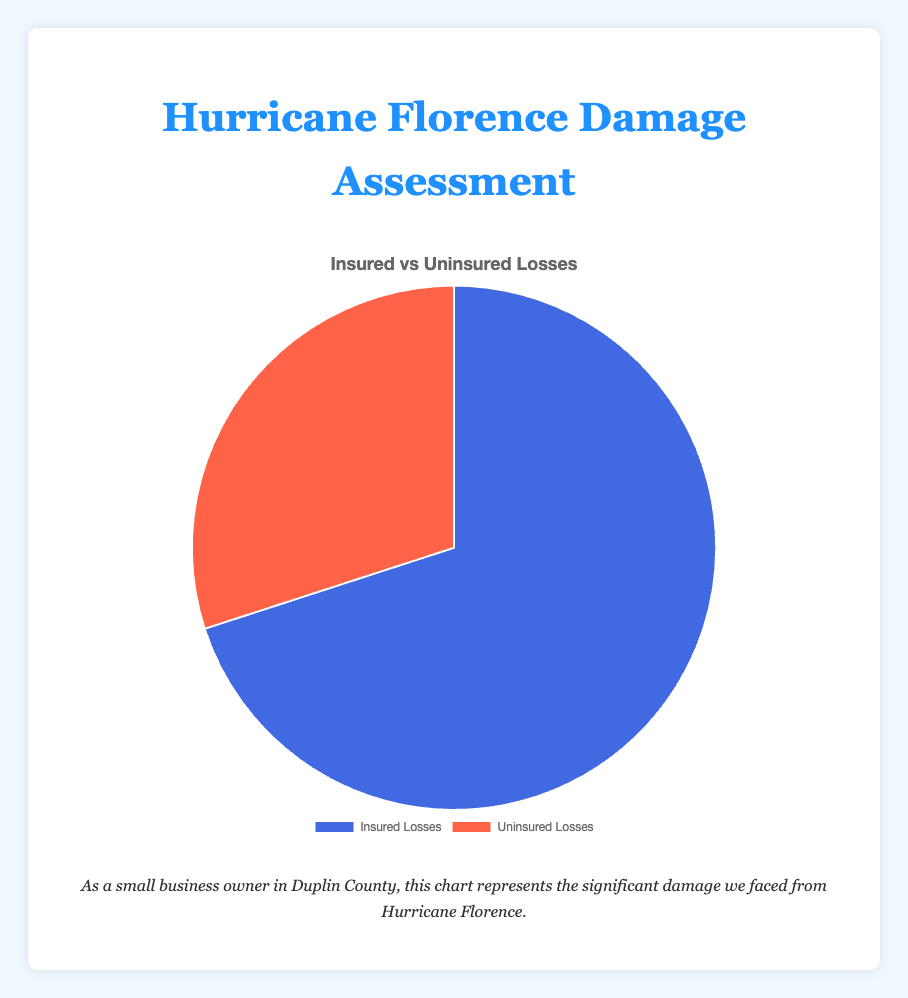What's the total value of uninsured losses? The figure shows that the pie chart represents uninsured losses as one segment, and its value is displayed as $1,500,000.
Answer: $1,500,000 What proportion of the total losses do insured losses represent? Insured losses are $3,500,000 out of a total loss of $5,000,000. To find the proportion, divide $3,500,000 by $5,000,000 and multiply by 100%. \( \frac{3,500,000}{5,000,000} \times 100 = 70\% \)
Answer: 70% Which color represents uninsured losses on the chart? The uninsured losses are shown in red.
Answer: Red By how much do insured losses exceed uninsured losses? Insured losses are $3,500,000 and uninsured losses are $1,500,000. Subtract $1,500,000 from $3,500,000. \( $3,500,000 - $1,500,000 = $2,000,000 \)
Answer: $2,000,000 Are the insured losses greater than the uninsured losses? Yes, the figure shows that the insured losses ($3,500,000) are greater than the uninsured losses ($1,500,000).
Answer: Yes What percentage of the total losses are uninsured? Uninsured losses are $1,500,000 and the total losses are $5,000,000. To find the percentage, divide $1,500,000 by $5,000,000 and multiply by 100%. \( \frac{1,500,000}{5,000,000} \times 100 = 30\% \)
Answer: 30% What is the total value of insured and uninsured losses combined? Add the insured losses ($3,500,000) and the uninsured losses ($1,500,000) to find the total. \( $3,500,000 + $1,500,000 = $5,000,000 \)
Answer: $5,000,000 What feature of the pie chart can help you distinguish insured losses from uninsured losses at a glance? The pie chart uses different colors to represent insured losses (blue) and uninsured losses (red), making it easy to distinguish between them.
Answer: Different colors 